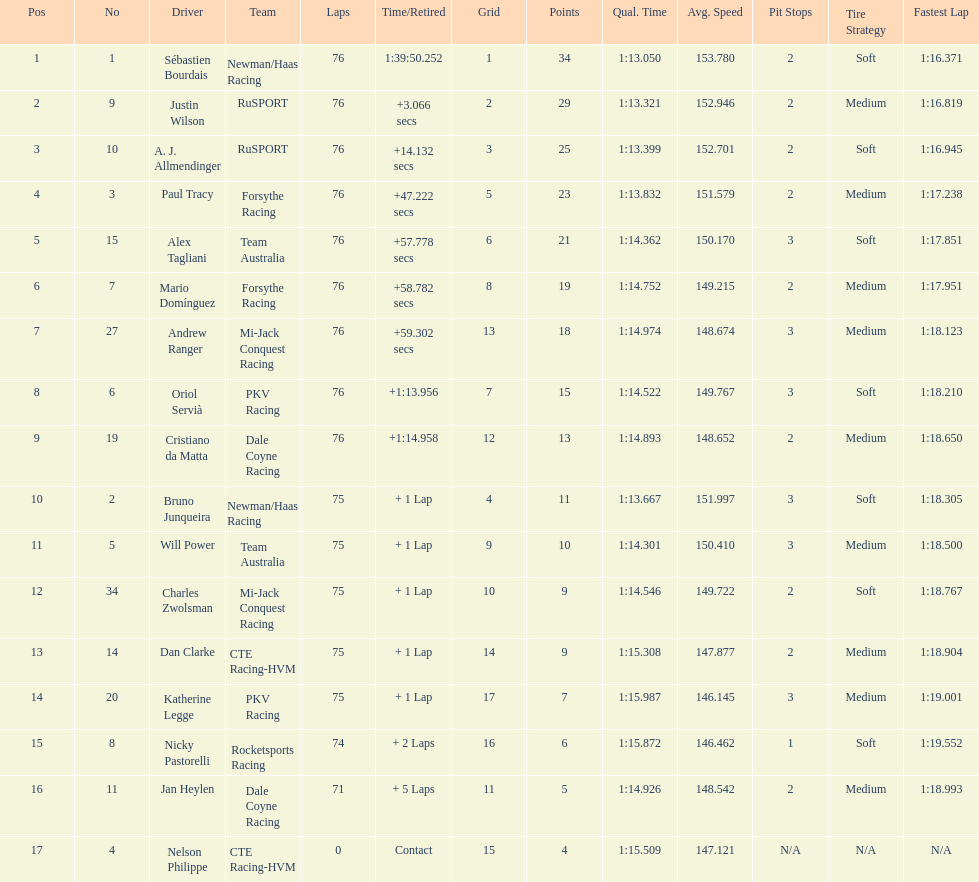How many positions are held by canada? 3. 